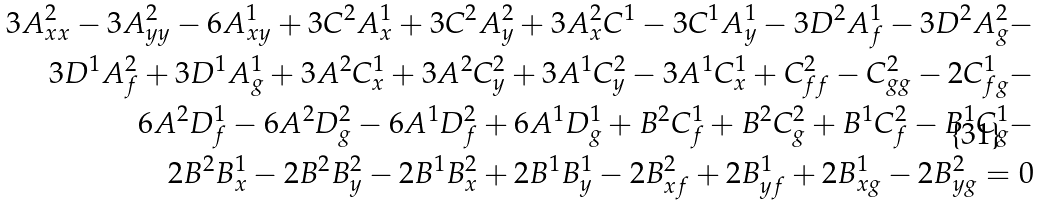<formula> <loc_0><loc_0><loc_500><loc_500>3 A _ { x x } ^ { 2 } - 3 A _ { y y } ^ { 2 } - 6 A _ { x y } ^ { 1 } + 3 C ^ { 2 } A _ { x } ^ { 1 } + 3 C ^ { 2 } A _ { y } ^ { 2 } + 3 A _ { x } ^ { 2 } C ^ { 1 } - 3 C ^ { 1 } A _ { y } ^ { 1 } - 3 D ^ { 2 } A _ { f } ^ { 1 } - 3 D ^ { 2 } A _ { g } ^ { 2 } - \\ 3 D ^ { 1 } A _ { f } ^ { 2 } + 3 D ^ { 1 } A _ { g } ^ { 1 } + 3 A ^ { 2 } C _ { x } ^ { 1 } + 3 A ^ { 2 } C _ { y } ^ { 2 } + 3 A ^ { 1 } C _ { y } ^ { 2 } - 3 A ^ { 1 } C _ { x } ^ { 1 } + C _ { f f } ^ { 2 } - C _ { g g } ^ { 2 } - 2 C _ { f g } ^ { 1 } - \\ 6 A ^ { 2 } D _ { f } ^ { 1 } - 6 A ^ { 2 } D _ { g } ^ { 2 } - 6 A ^ { 1 } D _ { f } ^ { 2 } + 6 A ^ { 1 } D _ { g } ^ { 1 } + B ^ { 2 } C _ { f } ^ { 1 } + B ^ { 2 } C _ { g } ^ { 2 } + B ^ { 1 } C _ { f } ^ { 2 } - B ^ { 1 } C _ { g } ^ { 1 } - \\ 2 B ^ { 2 } B _ { x } ^ { 1 } - 2 B ^ { 2 } B _ { y } ^ { 2 } - 2 B ^ { 1 } B _ { x } ^ { 2 } + 2 B ^ { 1 } B _ { y } ^ { 1 } - 2 B _ { x f } ^ { 2 } + 2 B _ { y f } ^ { 1 } + 2 B _ { x g } ^ { 1 } - 2 B _ { y g } ^ { 2 } = 0</formula> 